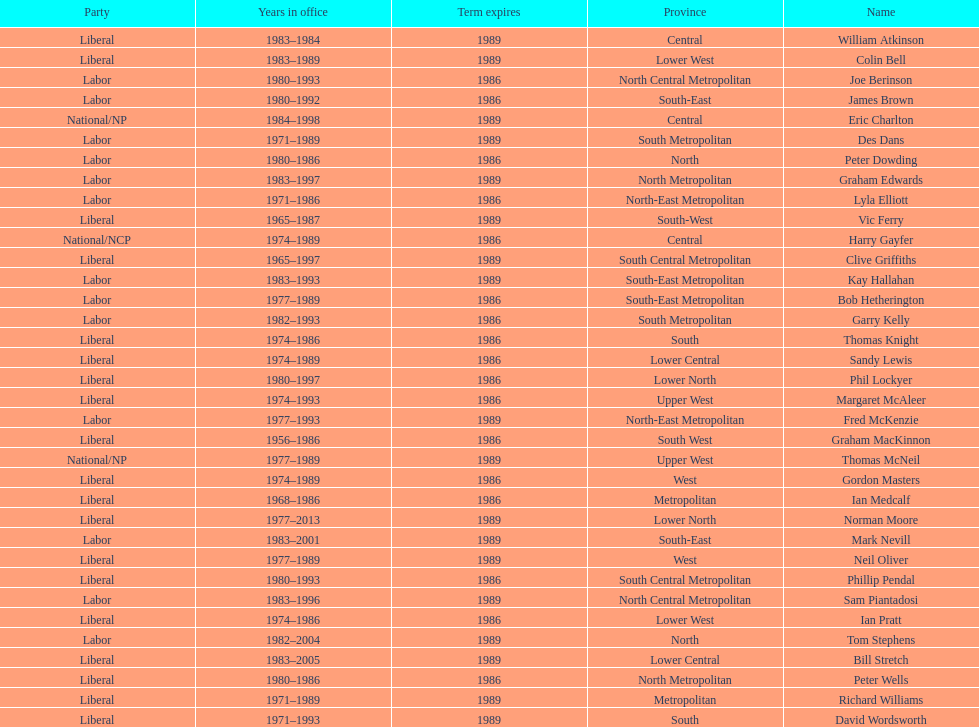How many members were party of lower west province? 2. 